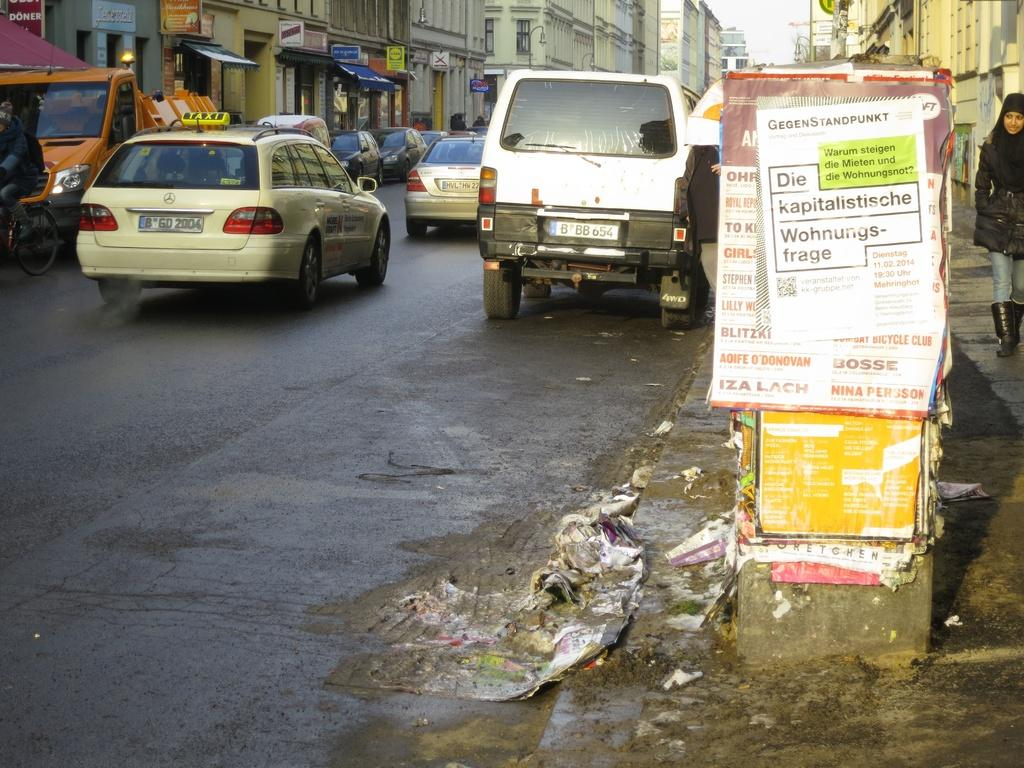<image>
Summarize the visual content of the image. A sign beside a busy road that has the words Die kapitalistische. 